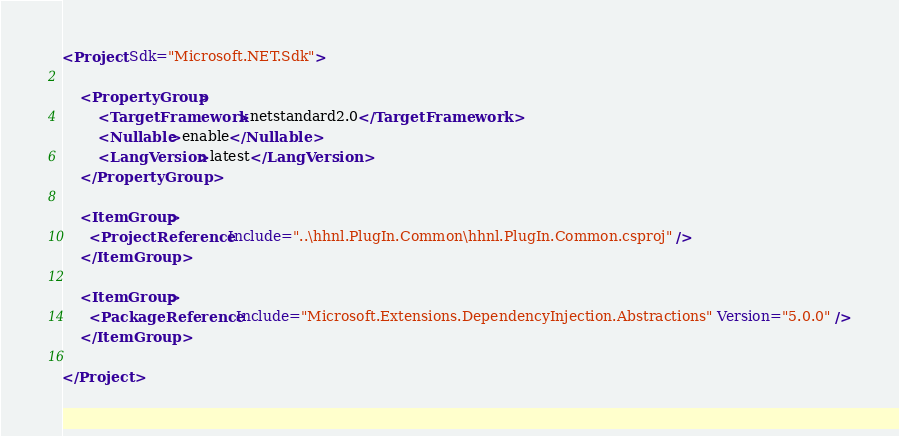Convert code to text. <code><loc_0><loc_0><loc_500><loc_500><_XML_><Project Sdk="Microsoft.NET.Sdk">

    <PropertyGroup>
        <TargetFramework>netstandard2.0</TargetFramework>
        <Nullable>enable</Nullable>
        <LangVersion>latest</LangVersion>
    </PropertyGroup>

    <ItemGroup>
      <ProjectReference Include="..\hhnl.PlugIn.Common\hhnl.PlugIn.Common.csproj" />
    </ItemGroup>

    <ItemGroup>
      <PackageReference Include="Microsoft.Extensions.DependencyInjection.Abstractions" Version="5.0.0" />
    </ItemGroup>

</Project>
</code> 